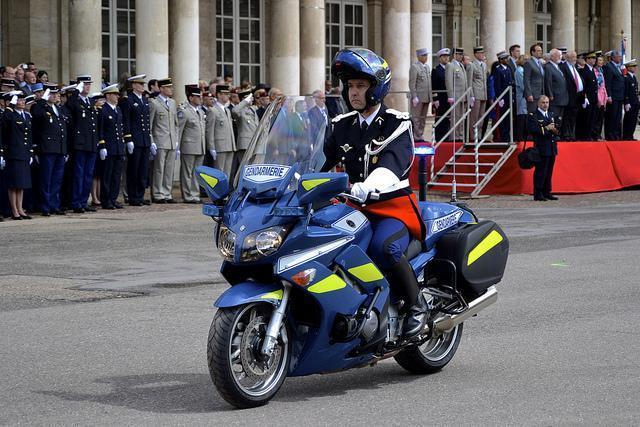How many people are there?
Give a very brief answer. 9. 